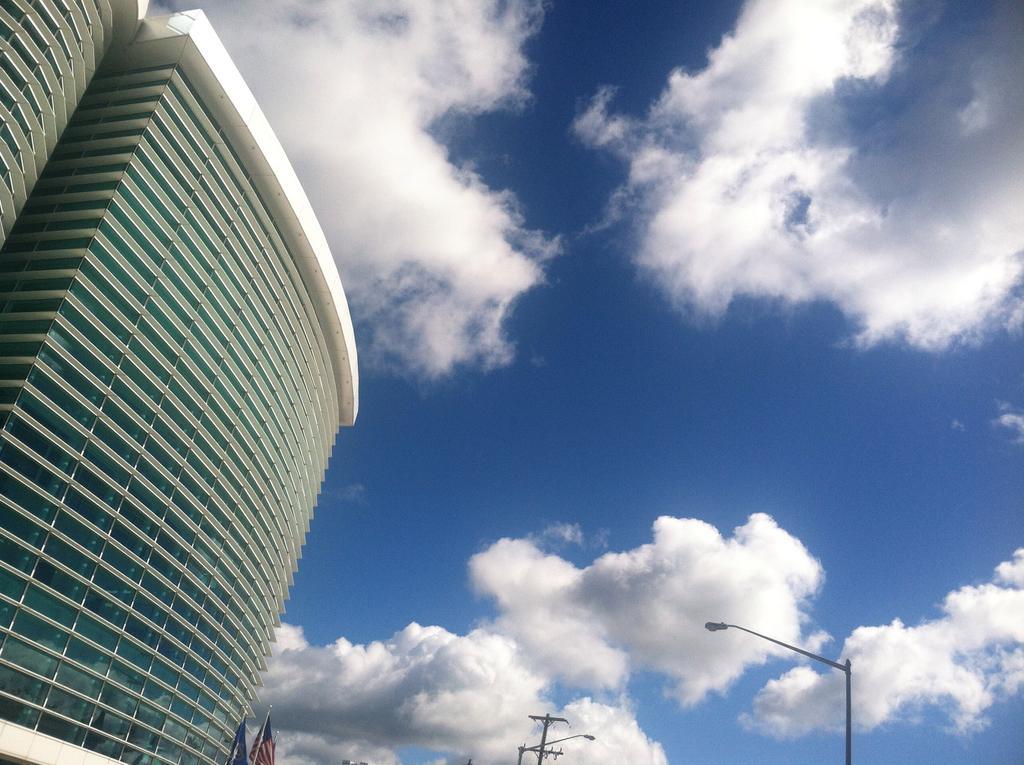Describe this image in one or two sentences. In the image we can see their buildings and there are street light poles. There is a cloudy sky. 